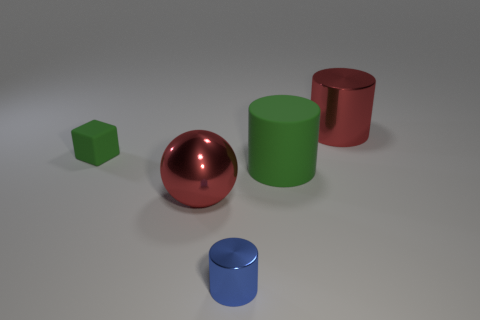There is a metal object that is the same color as the large ball; what size is it?
Provide a short and direct response. Large. What is the small green block that is on the left side of the red metal cylinder made of?
Provide a succinct answer. Rubber. Is the number of green matte blocks that are to the right of the tiny blue shiny object the same as the number of green cubes that are on the right side of the big metallic cylinder?
Your answer should be very brief. Yes. There is a big matte object that is the same shape as the blue shiny thing; what color is it?
Provide a succinct answer. Green. Is there any other thing that is the same color as the small metal cylinder?
Provide a succinct answer. No. How many rubber things are either small purple things or big red cylinders?
Offer a very short reply. 0. Is the metallic ball the same color as the large metallic cylinder?
Your answer should be very brief. Yes. Is the number of big metal objects on the right side of the blue thing greater than the number of purple shiny cylinders?
Your answer should be very brief. Yes. What number of other objects are the same material as the tiny green cube?
Provide a succinct answer. 1. How many large objects are either blue spheres or green rubber things?
Offer a terse response. 1. 